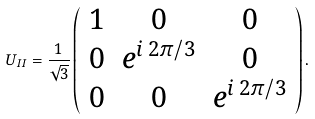Convert formula to latex. <formula><loc_0><loc_0><loc_500><loc_500>U _ { I I } = \frac { 1 } { \sqrt { 3 } } \left ( \begin{array} { c c c } 1 & 0 & 0 \\ 0 & e ^ { i \, 2 \pi / 3 } & 0 \\ 0 & 0 & e ^ { i \, 2 \pi / 3 } \end{array} \right ) .</formula> 